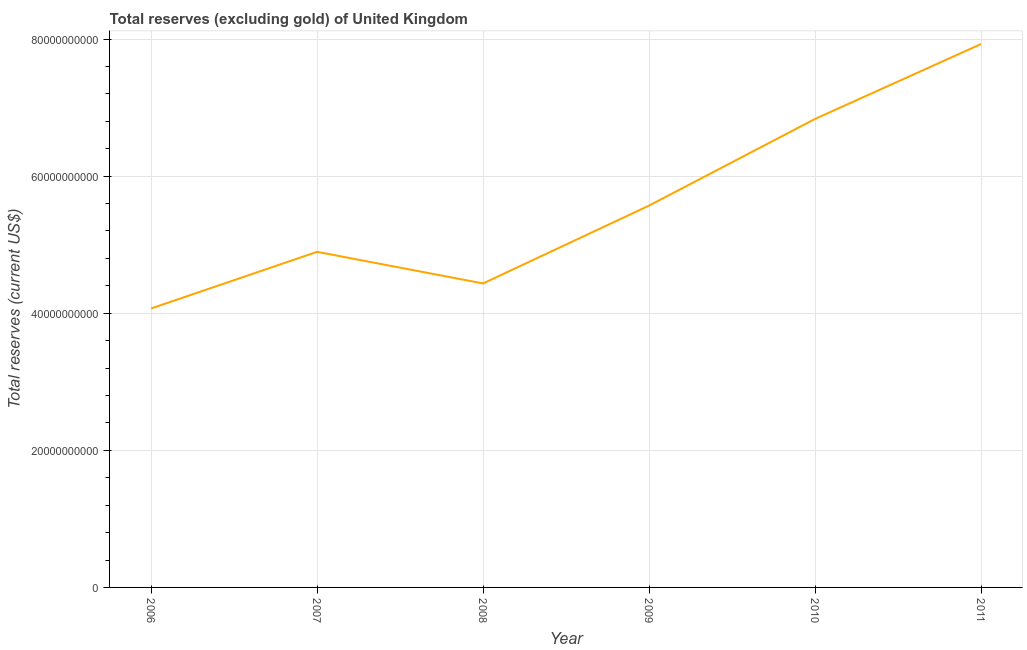What is the total reserves (excluding gold) in 2006?
Keep it short and to the point. 4.07e+1. Across all years, what is the maximum total reserves (excluding gold)?
Ensure brevity in your answer.  7.93e+1. Across all years, what is the minimum total reserves (excluding gold)?
Make the answer very short. 4.07e+1. In which year was the total reserves (excluding gold) maximum?
Your answer should be compact. 2011. What is the sum of the total reserves (excluding gold)?
Offer a very short reply. 3.37e+11. What is the difference between the total reserves (excluding gold) in 2006 and 2008?
Make the answer very short. -3.65e+09. What is the average total reserves (excluding gold) per year?
Your answer should be very brief. 5.62e+1. What is the median total reserves (excluding gold)?
Your answer should be very brief. 5.23e+1. In how many years, is the total reserves (excluding gold) greater than 76000000000 US$?
Make the answer very short. 1. What is the ratio of the total reserves (excluding gold) in 2007 to that in 2009?
Provide a succinct answer. 0.88. Is the total reserves (excluding gold) in 2009 less than that in 2011?
Your answer should be very brief. Yes. Is the difference between the total reserves (excluding gold) in 2007 and 2009 greater than the difference between any two years?
Offer a terse response. No. What is the difference between the highest and the second highest total reserves (excluding gold)?
Give a very brief answer. 1.09e+1. Is the sum of the total reserves (excluding gold) in 2009 and 2011 greater than the maximum total reserves (excluding gold) across all years?
Your answer should be very brief. Yes. What is the difference between the highest and the lowest total reserves (excluding gold)?
Your response must be concise. 3.86e+1. In how many years, is the total reserves (excluding gold) greater than the average total reserves (excluding gold) taken over all years?
Provide a short and direct response. 2. How many lines are there?
Your answer should be very brief. 1. How many years are there in the graph?
Provide a succinct answer. 6. Are the values on the major ticks of Y-axis written in scientific E-notation?
Offer a terse response. No. Does the graph contain any zero values?
Your response must be concise. No. What is the title of the graph?
Your answer should be compact. Total reserves (excluding gold) of United Kingdom. What is the label or title of the X-axis?
Your response must be concise. Year. What is the label or title of the Y-axis?
Give a very brief answer. Total reserves (current US$). What is the Total reserves (current US$) in 2006?
Offer a very short reply. 4.07e+1. What is the Total reserves (current US$) of 2007?
Give a very brief answer. 4.90e+1. What is the Total reserves (current US$) in 2008?
Give a very brief answer. 4.43e+1. What is the Total reserves (current US$) in 2009?
Your response must be concise. 5.57e+1. What is the Total reserves (current US$) in 2010?
Give a very brief answer. 6.83e+1. What is the Total reserves (current US$) of 2011?
Your answer should be very brief. 7.93e+1. What is the difference between the Total reserves (current US$) in 2006 and 2007?
Keep it short and to the point. -8.26e+09. What is the difference between the Total reserves (current US$) in 2006 and 2008?
Your answer should be very brief. -3.65e+09. What is the difference between the Total reserves (current US$) in 2006 and 2009?
Give a very brief answer. -1.50e+1. What is the difference between the Total reserves (current US$) in 2006 and 2010?
Make the answer very short. -2.76e+1. What is the difference between the Total reserves (current US$) in 2006 and 2011?
Provide a short and direct response. -3.86e+1. What is the difference between the Total reserves (current US$) in 2007 and 2008?
Your response must be concise. 4.61e+09. What is the difference between the Total reserves (current US$) in 2007 and 2009?
Give a very brief answer. -6.74e+09. What is the difference between the Total reserves (current US$) in 2007 and 2010?
Make the answer very short. -1.94e+1. What is the difference between the Total reserves (current US$) in 2007 and 2011?
Offer a very short reply. -3.03e+1. What is the difference between the Total reserves (current US$) in 2008 and 2009?
Your answer should be compact. -1.14e+1. What is the difference between the Total reserves (current US$) in 2008 and 2010?
Ensure brevity in your answer.  -2.40e+1. What is the difference between the Total reserves (current US$) in 2008 and 2011?
Keep it short and to the point. -3.49e+1. What is the difference between the Total reserves (current US$) in 2009 and 2010?
Make the answer very short. -1.26e+1. What is the difference between the Total reserves (current US$) in 2009 and 2011?
Your answer should be compact. -2.36e+1. What is the difference between the Total reserves (current US$) in 2010 and 2011?
Keep it short and to the point. -1.09e+1. What is the ratio of the Total reserves (current US$) in 2006 to that in 2007?
Your answer should be very brief. 0.83. What is the ratio of the Total reserves (current US$) in 2006 to that in 2008?
Give a very brief answer. 0.92. What is the ratio of the Total reserves (current US$) in 2006 to that in 2009?
Offer a very short reply. 0.73. What is the ratio of the Total reserves (current US$) in 2006 to that in 2010?
Your answer should be very brief. 0.59. What is the ratio of the Total reserves (current US$) in 2006 to that in 2011?
Your answer should be compact. 0.51. What is the ratio of the Total reserves (current US$) in 2007 to that in 2008?
Your answer should be compact. 1.1. What is the ratio of the Total reserves (current US$) in 2007 to that in 2009?
Offer a terse response. 0.88. What is the ratio of the Total reserves (current US$) in 2007 to that in 2010?
Provide a short and direct response. 0.72. What is the ratio of the Total reserves (current US$) in 2007 to that in 2011?
Provide a short and direct response. 0.62. What is the ratio of the Total reserves (current US$) in 2008 to that in 2009?
Offer a terse response. 0.8. What is the ratio of the Total reserves (current US$) in 2008 to that in 2010?
Offer a very short reply. 0.65. What is the ratio of the Total reserves (current US$) in 2008 to that in 2011?
Make the answer very short. 0.56. What is the ratio of the Total reserves (current US$) in 2009 to that in 2010?
Provide a short and direct response. 0.81. What is the ratio of the Total reserves (current US$) in 2009 to that in 2011?
Give a very brief answer. 0.7. What is the ratio of the Total reserves (current US$) in 2010 to that in 2011?
Your answer should be very brief. 0.86. 